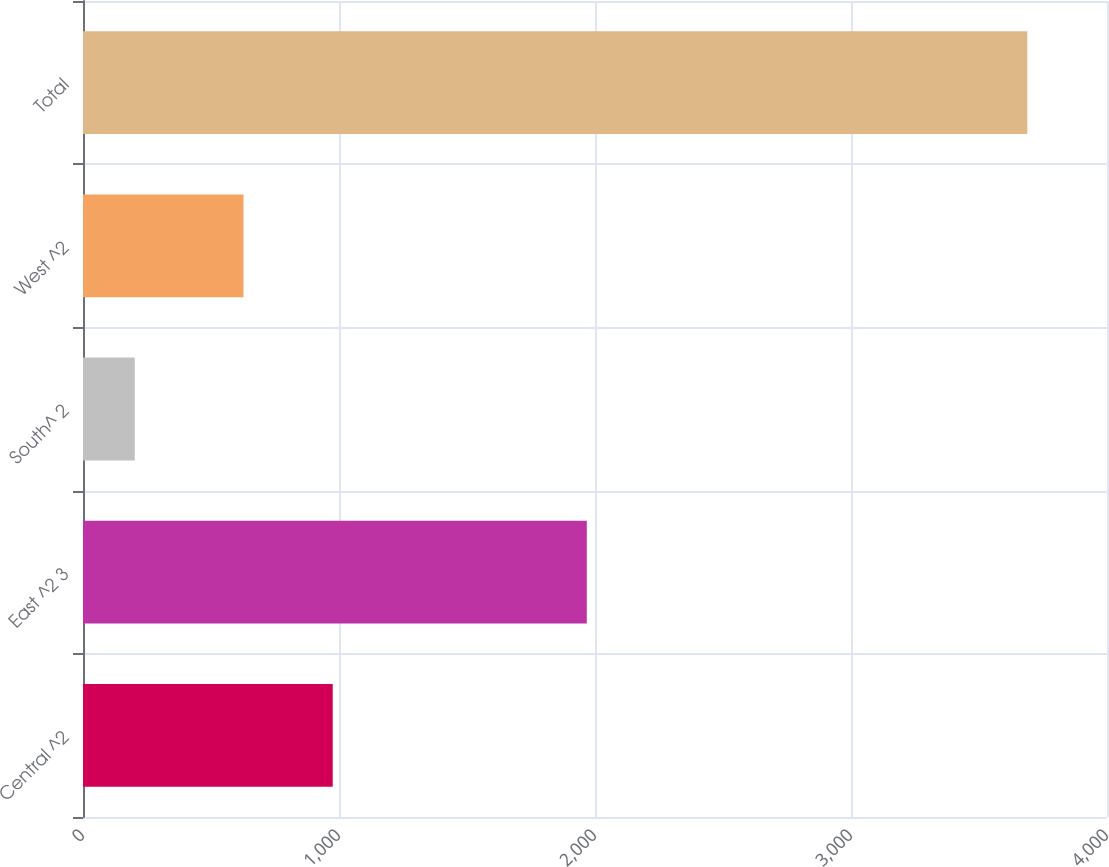<chart> <loc_0><loc_0><loc_500><loc_500><bar_chart><fcel>Central ^2<fcel>East ^2 3<fcel>South^ 2<fcel>West ^2<fcel>Total<nl><fcel>975.55<fcel>1968<fcel>202.2<fcel>626.9<fcel>3688.7<nl></chart> 